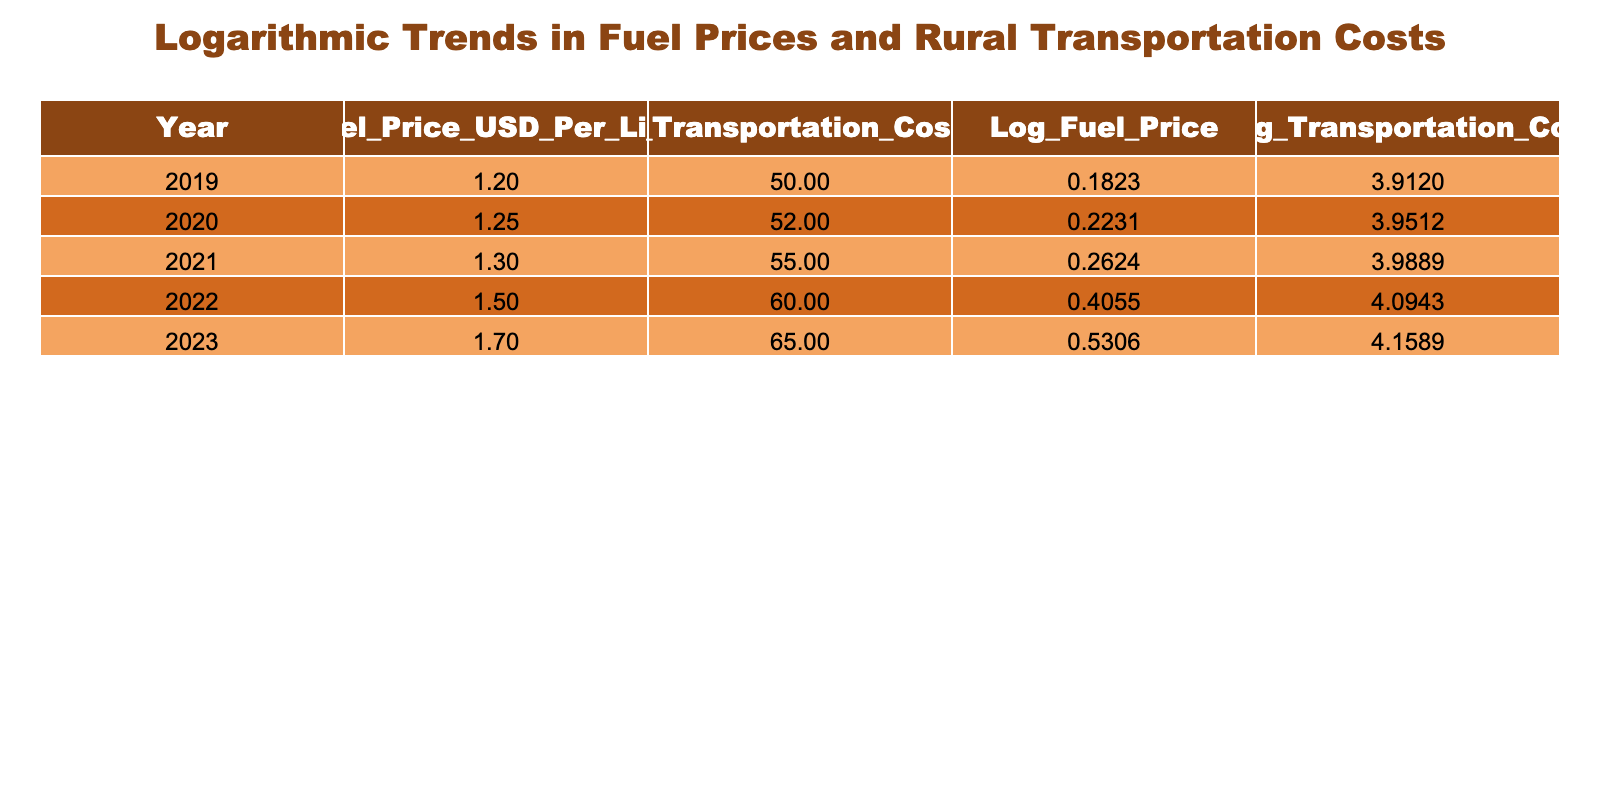What was the fuel price in 2021? The table shows that in 2021, the fuel price was listed as 1.30 USD per liter.
Answer: 1.30 USD per liter In which year was the rural transportation cost the highest? By inspecting the Rural Transportation Cost column, the highest value is 65 USD, which corresponds to the year 2023.
Answer: 2023 What is the average fuel price over the five years? To find the average, we sum the fuel prices: 1.20 + 1.25 + 1.30 + 1.50 + 1.70 = 7.25. Then we divide by 5, resulting in an average of 7.25 / 5 = 1.45 USD per liter.
Answer: 1.45 USD per liter Is the logarithmic value of the fuel price in 2022 greater than that in 2021? In the table, the logarithmic value for 2022 is 0.4055, and for 2021 it is 0.2624. Since 0.4055 is greater than 0.2624, the answer is yes.
Answer: Yes What is the increase in rural transportation cost from 2019 to 2023? The cost in 2019 was 50 USD, and in 2023 it was 65 USD. The difference is 65 - 50 = 15 USD, indicating an increase of 15 USD over the five years.
Answer: 15 USD 